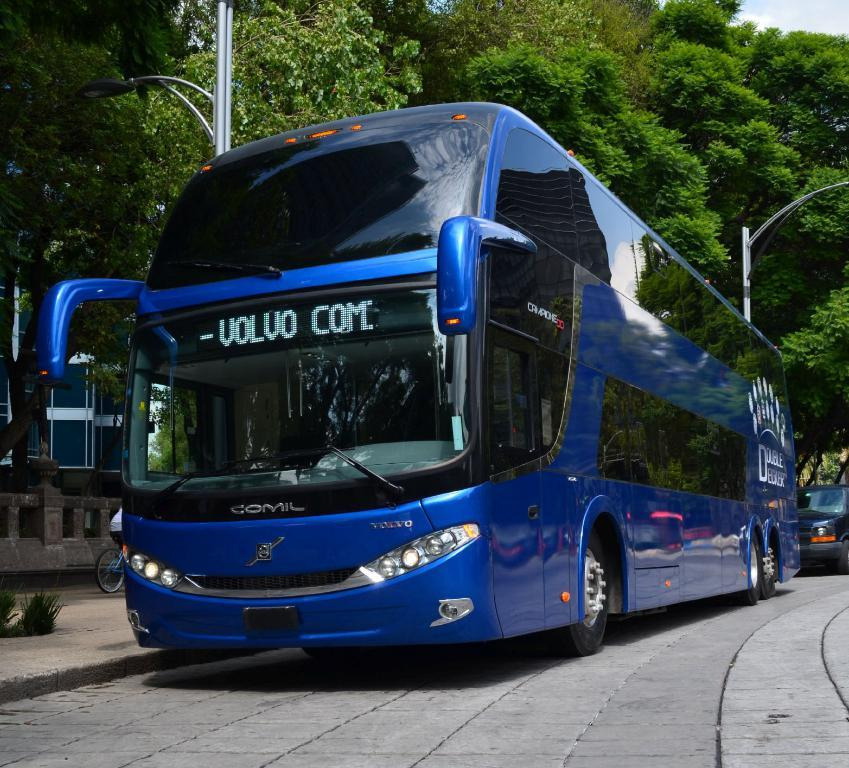What is located in the foreground of the image? There is a road in the foreground of the image. What is the main subject in the middle of the image? There is a big bus in the middle of the image. What color is the bus? The bus is blue in color. What can be seen at the top of the image? There are trees visible at the top of the image. What type of shoe design can be seen on the bus in the image? There are no shoes or shoe designs present on the bus in the image; it is a blue bus with no visible designs. What country is depicted on the flag flying from the bus in the image? There is no flag or country depicted on the bus in the image. 